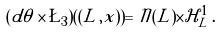Convert formula to latex. <formula><loc_0><loc_0><loc_500><loc_500>( d \theta \times \L _ { 3 } ) ( ( L , x ) ) = \mathcal { N } ( L ) \times \mathcal { H } _ { L } ^ { 1 } \, .</formula> 